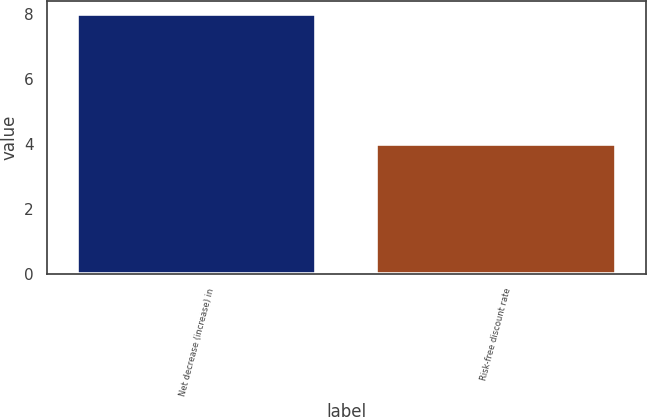Convert chart to OTSL. <chart><loc_0><loc_0><loc_500><loc_500><bar_chart><fcel>Net decrease (increase) in<fcel>Risk-free discount rate<nl><fcel>8<fcel>4<nl></chart> 